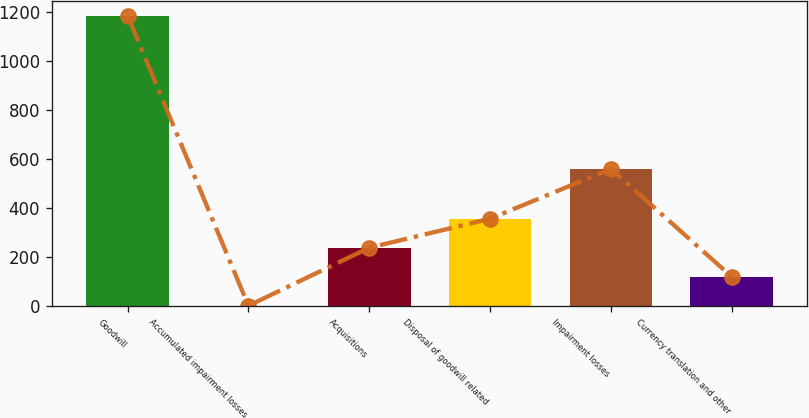Convert chart to OTSL. <chart><loc_0><loc_0><loc_500><loc_500><bar_chart><fcel>Goodwill<fcel>Accumulated impairment losses<fcel>Acquisitions<fcel>Disposal of goodwill related<fcel>Impairment losses<fcel>Currency translation and other<nl><fcel>1185<fcel>1.85<fcel>238.49<fcel>356.81<fcel>560<fcel>120.17<nl></chart> 